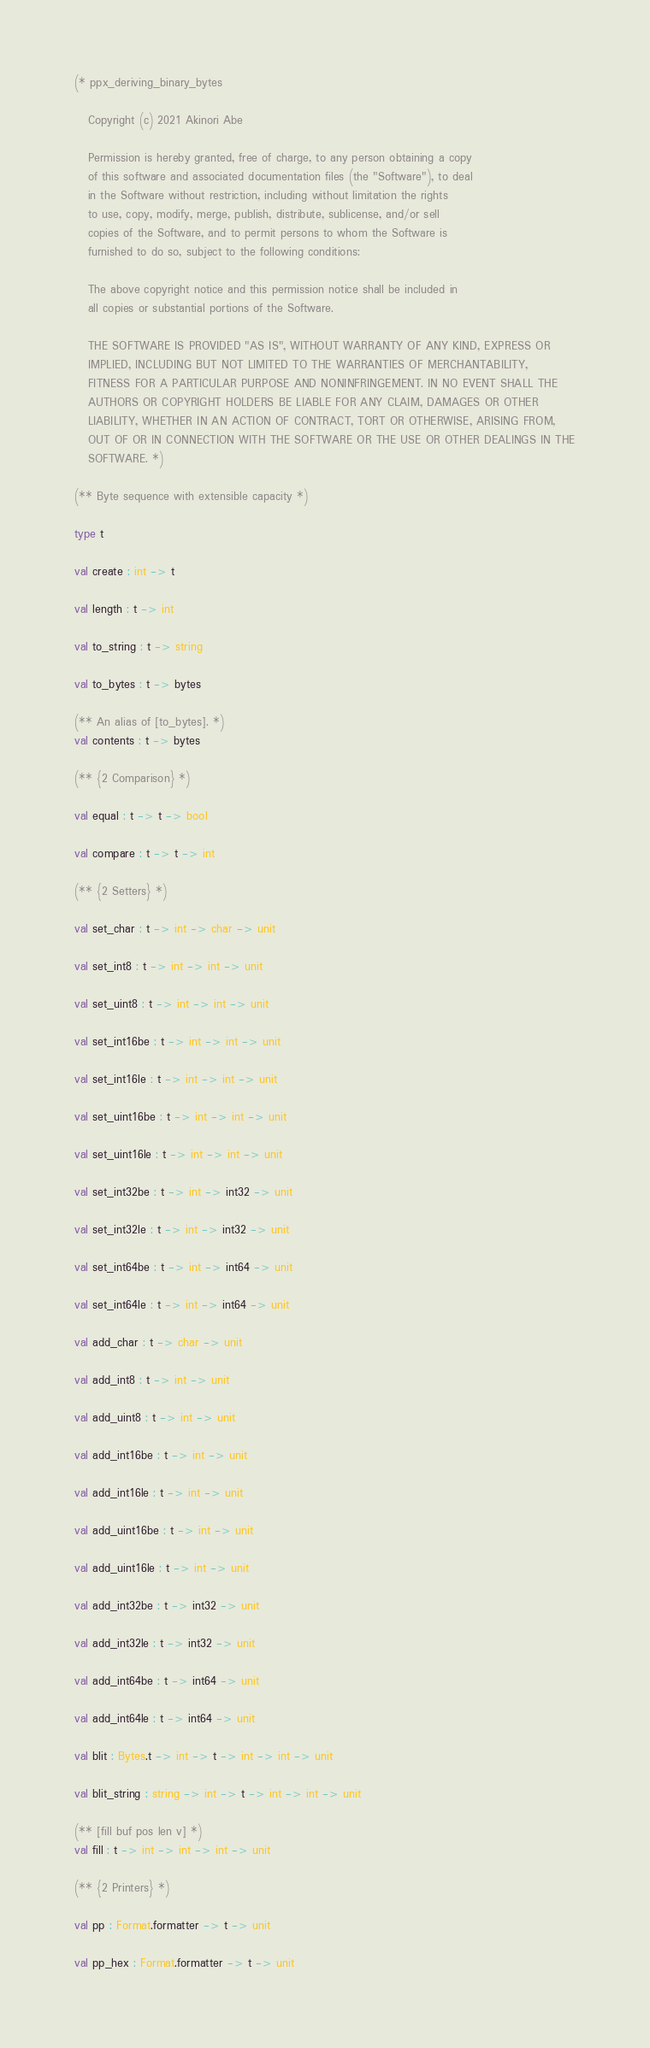Convert code to text. <code><loc_0><loc_0><loc_500><loc_500><_OCaml_>(* ppx_deriving_binary_bytes

   Copyright (c) 2021 Akinori Abe

   Permission is hereby granted, free of charge, to any person obtaining a copy
   of this software and associated documentation files (the "Software"), to deal
   in the Software without restriction, including without limitation the rights
   to use, copy, modify, merge, publish, distribute, sublicense, and/or sell
   copies of the Software, and to permit persons to whom the Software is
   furnished to do so, subject to the following conditions:

   The above copyright notice and this permission notice shall be included in
   all copies or substantial portions of the Software.

   THE SOFTWARE IS PROVIDED "AS IS", WITHOUT WARRANTY OF ANY KIND, EXPRESS OR
   IMPLIED, INCLUDING BUT NOT LIMITED TO THE WARRANTIES OF MERCHANTABILITY,
   FITNESS FOR A PARTICULAR PURPOSE AND NONINFRINGEMENT. IN NO EVENT SHALL THE
   AUTHORS OR COPYRIGHT HOLDERS BE LIABLE FOR ANY CLAIM, DAMAGES OR OTHER
   LIABILITY, WHETHER IN AN ACTION OF CONTRACT, TORT OR OTHERWISE, ARISING FROM,
   OUT OF OR IN CONNECTION WITH THE SOFTWARE OR THE USE OR OTHER DEALINGS IN THE
   SOFTWARE. *)

(** Byte sequence with extensible capacity *)

type t

val create : int -> t

val length : t -> int

val to_string : t -> string

val to_bytes : t -> bytes

(** An alias of [to_bytes]. *)
val contents : t -> bytes

(** {2 Comparison} *)

val equal : t -> t -> bool

val compare : t -> t -> int

(** {2 Setters} *)

val set_char : t -> int -> char -> unit

val set_int8 : t -> int -> int -> unit

val set_uint8 : t -> int -> int -> unit

val set_int16be : t -> int -> int -> unit

val set_int16le : t -> int -> int -> unit

val set_uint16be : t -> int -> int -> unit

val set_uint16le : t -> int -> int -> unit

val set_int32be : t -> int -> int32 -> unit

val set_int32le : t -> int -> int32 -> unit

val set_int64be : t -> int -> int64 -> unit

val set_int64le : t -> int -> int64 -> unit

val add_char : t -> char -> unit

val add_int8 : t -> int -> unit

val add_uint8 : t -> int -> unit

val add_int16be : t -> int -> unit

val add_int16le : t -> int -> unit

val add_uint16be : t -> int -> unit

val add_uint16le : t -> int -> unit

val add_int32be : t -> int32 -> unit

val add_int32le : t -> int32 -> unit

val add_int64be : t -> int64 -> unit

val add_int64le : t -> int64 -> unit

val blit : Bytes.t -> int -> t -> int -> int -> unit

val blit_string : string -> int -> t -> int -> int -> unit

(** [fill buf pos len v] *)
val fill : t -> int -> int -> int -> unit

(** {2 Printers} *)

val pp : Format.formatter -> t -> unit

val pp_hex : Format.formatter -> t -> unit
</code> 